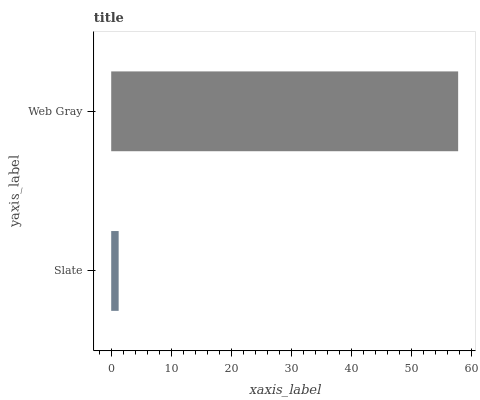Is Slate the minimum?
Answer yes or no. Yes. Is Web Gray the maximum?
Answer yes or no. Yes. Is Web Gray the minimum?
Answer yes or no. No. Is Web Gray greater than Slate?
Answer yes or no. Yes. Is Slate less than Web Gray?
Answer yes or no. Yes. Is Slate greater than Web Gray?
Answer yes or no. No. Is Web Gray less than Slate?
Answer yes or no. No. Is Web Gray the high median?
Answer yes or no. Yes. Is Slate the low median?
Answer yes or no. Yes. Is Slate the high median?
Answer yes or no. No. Is Web Gray the low median?
Answer yes or no. No. 